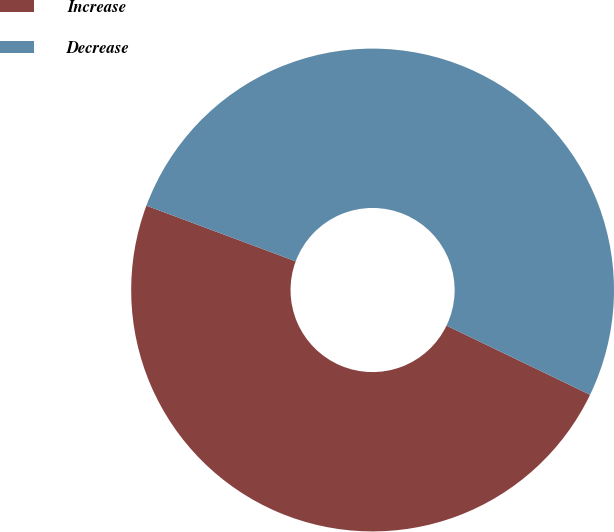Convert chart to OTSL. <chart><loc_0><loc_0><loc_500><loc_500><pie_chart><fcel>Increase<fcel>Decrease<nl><fcel>48.54%<fcel>51.46%<nl></chart> 